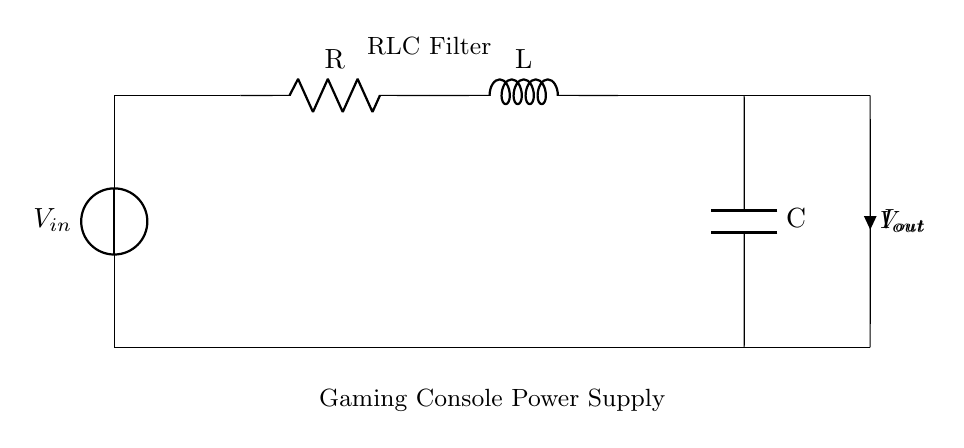What type of components are used in this circuit? The circuit includes three types of components: a resistor, an inductor, and a capacitor. These components are denoted as R, L, and C respectively in the diagram.
Answer: Resistor, Inductor, Capacitor What is the purpose of the RLC filter in this circuit? The RLC filter in this circuit is used to stabilize the output voltage by filtering out fluctuations and noise that can come from the power supply. This ensures a steady voltage output for the gaming console.
Answer: Stabilizing output voltage What is the significance of the current flowing through the circuit? The current flowing through the circuit, indicated as I_out, shows the flow of charge and is crucial for delivering power to the gaming console, making sure it operates correctly.
Answer: Power delivery What happens when the frequency of the input voltage increases? When the frequency of the input voltage increases, the reactance of the inductor also increases, potentially causing an imbalance in the circuit that can lead to higher output impedance, affecting voltage stability.
Answer: Increases reactance How does the arrangement of the RLC components affect the circuit's performance? The arrangement of the RLC components in series results in a combined impedance that influences how the circuit responds to different frequencies of the input voltage. This arrangement can help filter out certain frequencies while allowing others to pass, optimizing performance.
Answer: Filters frequencies What is the relationship between resistance, inductance, and capacitance in this circuit? The relationship between resistance, inductance, and capacitance determines the natural frequency and damping characteristics of the RLC circuit, affecting how effectively it can filter signals and provide a stable output voltage.
Answer: Determines natural frequency and damping What does V_out represent in this circuit? V_out represents the output voltage of the circuit, which is the voltage delivered to the gaming console after passing through the RLC filter, ensuring it's stable for optimal operation.
Answer: Output voltage 